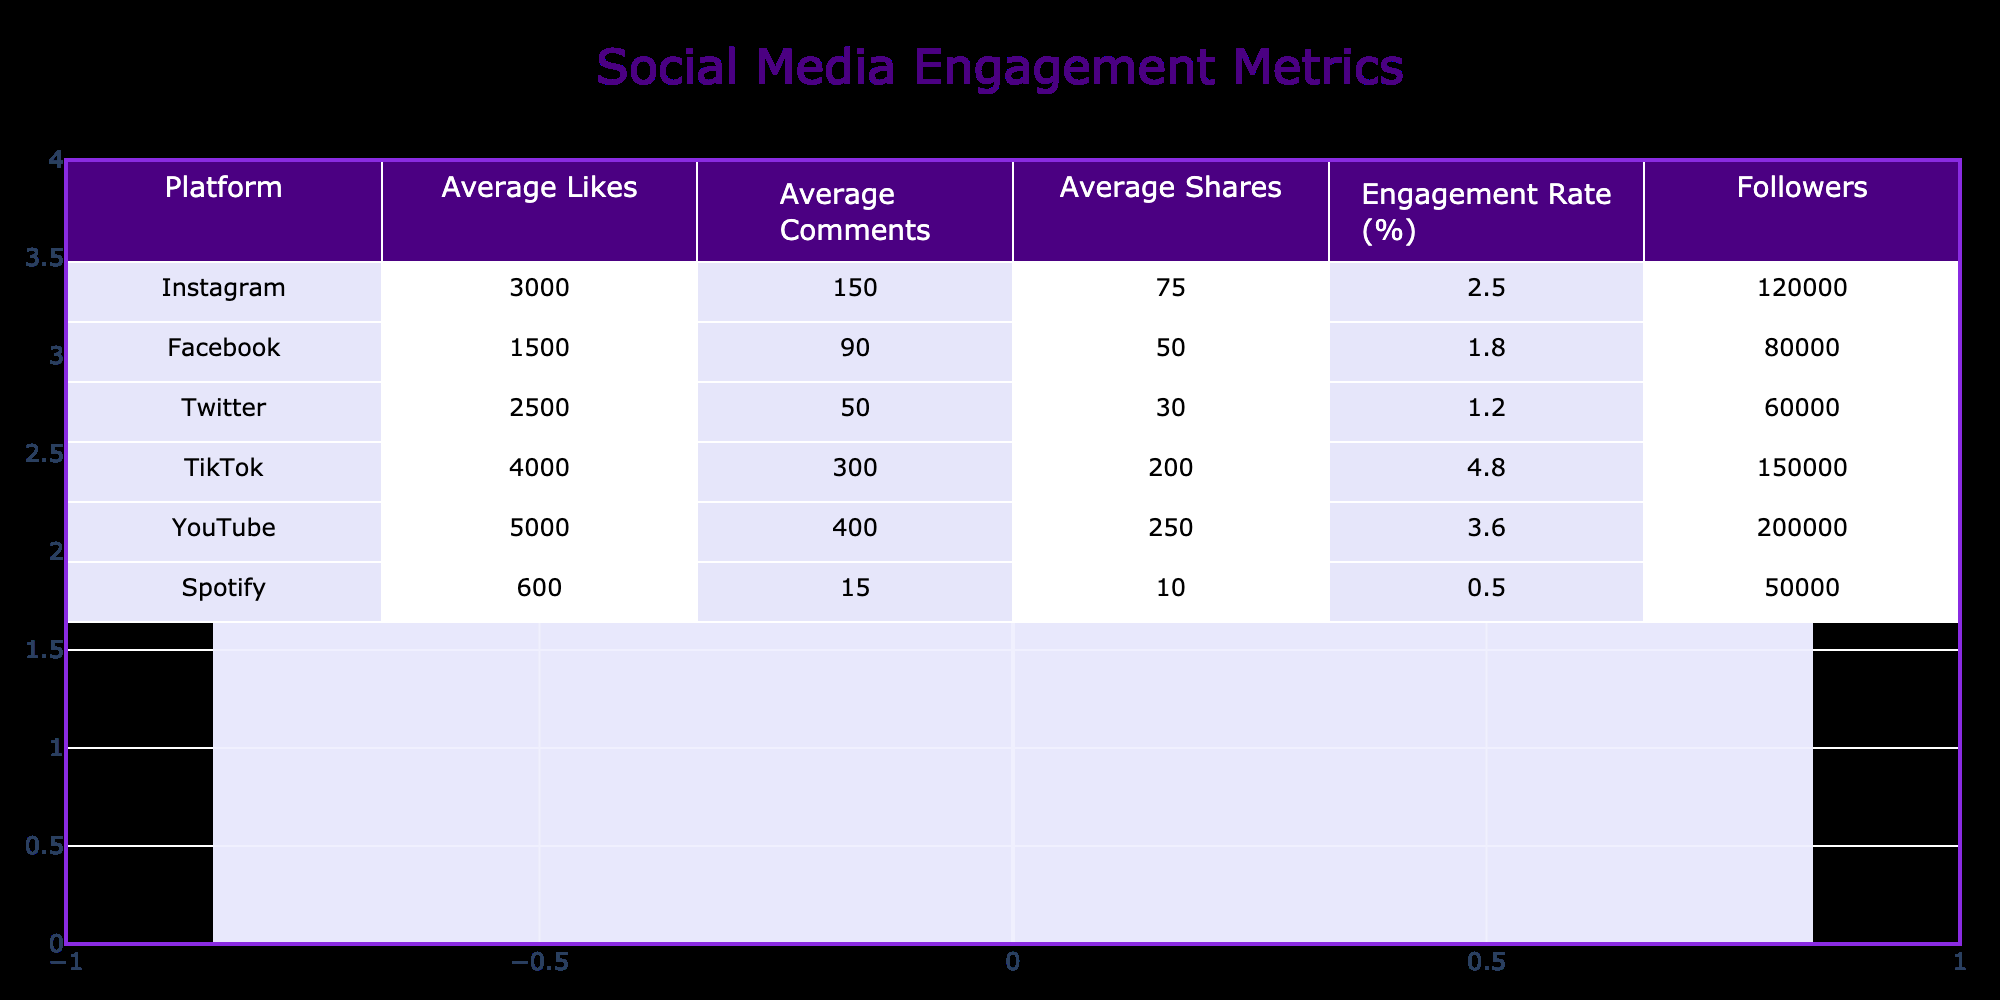What is the average number of likes across all platforms? To find the average number of likes, we sum all the average likes from the different platforms: 3000 (Instagram) + 1500 (Facebook) + 2500 (Twitter) + 4000 (TikTok) + 5000 (YouTube) + 600 (Spotify) = 19500. There are 6 platforms, so we divide the total by 6: 19500 / 6 = 3250.
Answer: 3250 Which platform has the highest engagement rate? The engagement rates for each platform are 2.5% (Instagram), 1.8% (Facebook), 1.2% (Twitter), 4.8% (TikTok), 3.6% (YouTube), and 0.5% (Spotify). The highest rate is 4.8%, which belongs to TikTok.
Answer: TikTok How many shares does YouTube average compared to Instagram? YouTube averages 250 shares and Instagram averages 75 shares. To find the difference: 250 - 75 = 175, thus YouTube averages 175 more shares than Instagram.
Answer: 175 Is TikTok's average number of comments higher than Instagram's? TikTok has an average of 300 comments and Instagram has 150 comments. Since 300 is greater than 150, TikTok's average comments are indeed higher than Instagram's.
Answer: Yes What is the total number of followers across all platforms? We add the number of followers for each platform: 120000 (Instagram) + 80000 (Facebook) + 60000 (Twitter) + 150000 (TikTok) + 200000 (YouTube) + 50000 (Spotify) = 600000.
Answer: 600000 Which platform has the lowest average likes? The average likes for Spotify are 600, which is less than Instagram (3000), Facebook (1500), Twitter (2500), TikTok (4000), and YouTube (5000). Therefore, Spotify has the lowest average likes.
Answer: Spotify What is the difference in average comments between YouTube and TikTok? YouTube averages 400 comments and TikTok averages 300 comments. To find the difference: 400 - 300 = 100, so YouTube averages 100 more comments than TikTok.
Answer: 100 Is the engagement rate for Spotify lower than that for Facebook? The engagement rates are 0.5% for Spotify and 1.8% for Facebook. Since 0.5% is less than 1.8%, Spotify's engagement rate is indeed lower than Facebook's.
Answer: Yes What percentage of average likes does Twitter have in comparison to TikTok? Twitter averages 2500 likes and TikTok averages 4000 likes. To find the percentage: (2500 / 4000) * 100 = 62.5%. Thus, Twitter has 62.5% of TikTok's average likes.
Answer: 62.5% 